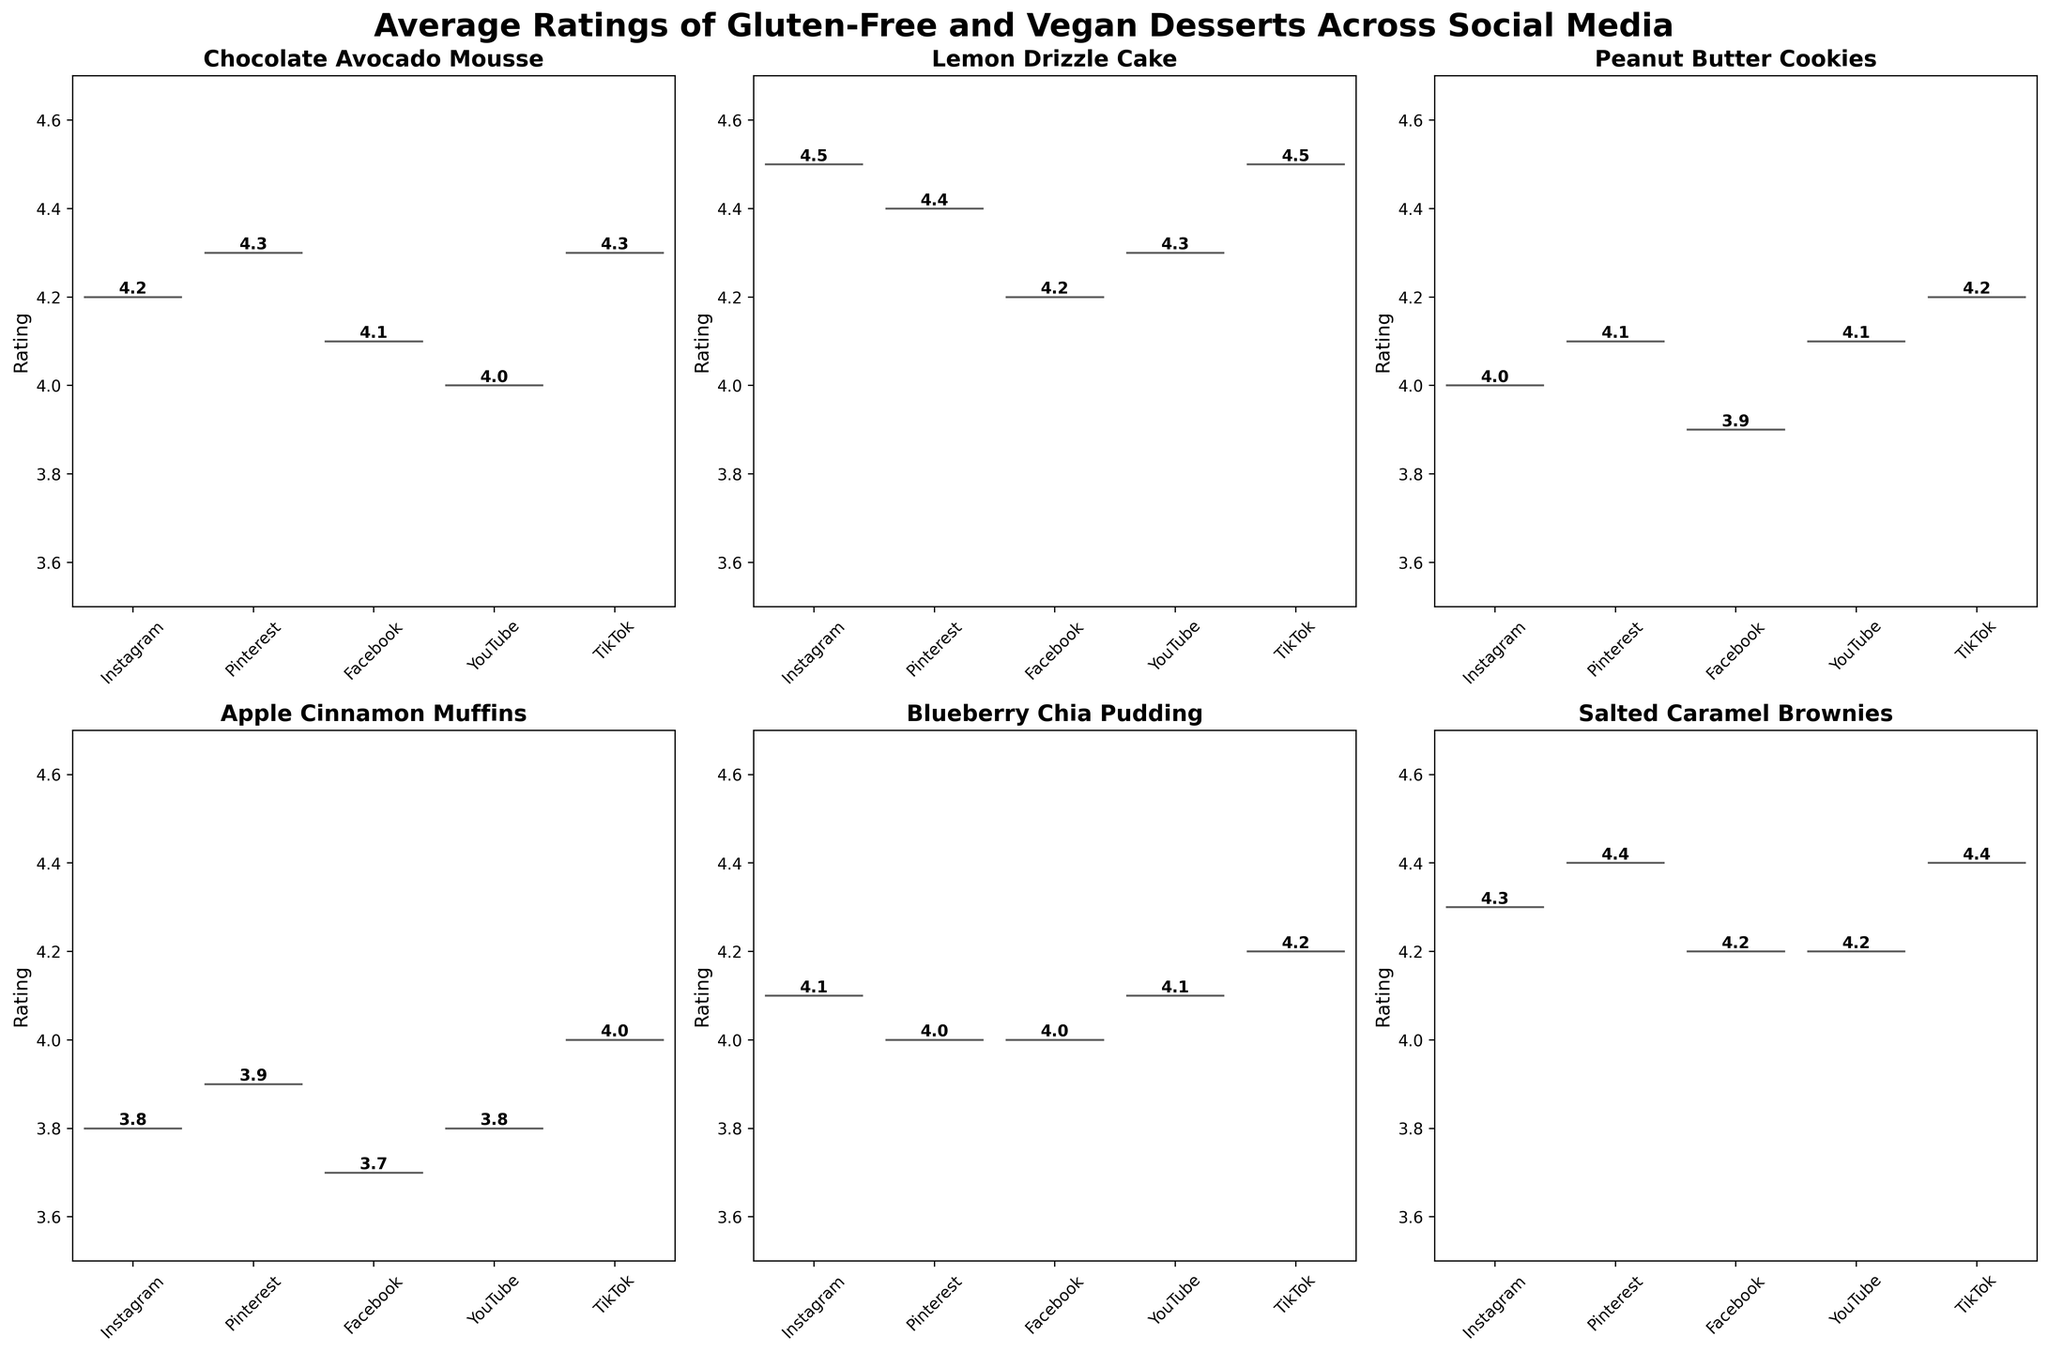What dessert has the highest average rating on Instagram? By looking at the violin plot for Instagram, we can see that the Lemon Drizzle Cake has the highest average rating of 4.5.
Answer: Lemon Drizzle Cake What's the range of ratings for the Apple Cinnamon Muffins across all platforms? Observing the subplots for Apple Cinnamon Muffins shows the ratings are 3.7 (Facebook) to 4.0 (TikTok). The range is 4.0 - 3.7 = 0.3.
Answer: 0.3 Which platform tends to have the highest ratings overall? Comparing the overall location of the ratings for each platform in the different violin plots, Pinterest and TikTok consistently show higher average ratings across the desserts.
Answer: Pinterest and TikTok How does the rating of Salted Caramel Brownies on Facebook compare to that on Pinterest? The ratings of Salted Caramel Brownies are 4.2 on Facebook and 4.4 on Pinterest. Since 4.4 is greater than 4.2, Pinterest has a higher rating.
Answer: Pinterest Is there a dessert that consistently has its ratings close to 4.1 across all platforms? By reviewing each subplot for consistencies, the Blueberry Chia Pudding frequently receives ratings close to 4.1 on all platforms.
Answer: Blueberry Chia Pudding Which dessert has the largest difference in ratings between TikTok and YouTube? Salted Caramel Brownies have a rating of 4.4 on TikTok and 4.2 on YouTube. The difference is 4.4 - 4.2 = 0.2. Checking the other values, TikTok and YouTube ratings for Apple Cinnamon Muffins show a larger difference (4.0 - 3.8 = 0.2). This pattern is also seen with another dessert.
Answer: Salted Caramel Brownies For Peanut Butter Cookies, which platform has the lowest rating, and what is it? Reviewing the Peanut Butter Cookies violin plots, Facebook has the lowest rating at 3.9.
Answer: Facebook at 3.9 What is the average rating of Lemon Drizzle Cake across all platforms? The Lemon Drizzle Cake has ratings of 4.5 (Instagram), 4.4 (Pinterest), 4.2 (Facebook), 4.3 (YouTube), and 4.5 (TikTok). Summing these: 4.5 + 4.4 + 4.2 + 4.3 + 4.5 = 21.9. Average is 21.9/5 = 4.38.
Answer: 4.38 